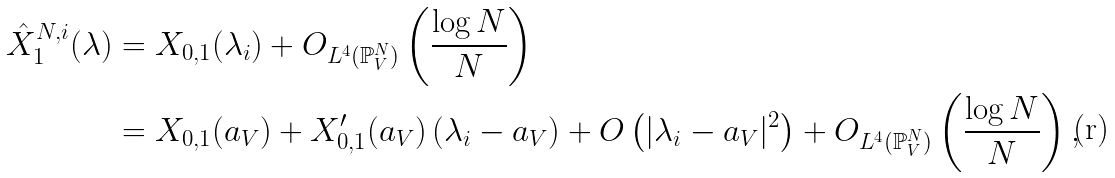<formula> <loc_0><loc_0><loc_500><loc_500>\hat { X } _ { 1 } ^ { N , i } ( \lambda ) & = X _ { 0 , 1 } ( \lambda _ { i } ) + O _ { L ^ { 4 } ( \mathbb { P } _ { V } ^ { N } ) } \left ( \frac { \log N } { N } \right ) \\ & = X _ { 0 , 1 } ( a _ { V } ) + X _ { 0 , 1 } ^ { \prime } ( a _ { V } ) \, ( \lambda _ { i } - a _ { V } ) + O \left ( | \lambda _ { i } - a _ { V } | ^ { 2 } \right ) + O _ { L ^ { 4 } ( \mathbb { P } _ { V } ^ { N } ) } \left ( \frac { \log N } { N } \right ) ,</formula> 